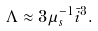Convert formula to latex. <formula><loc_0><loc_0><loc_500><loc_500>\Lambda \approx 3 \mu _ { s } ^ { - 1 } { \bar { i } } ^ { 3 } .</formula> 